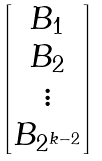Convert formula to latex. <formula><loc_0><loc_0><loc_500><loc_500>\begin{bmatrix} B _ { 1 } \\ B _ { 2 } \\ \vdots \\ B _ { 2 ^ { k - 2 } } \end{bmatrix}</formula> 